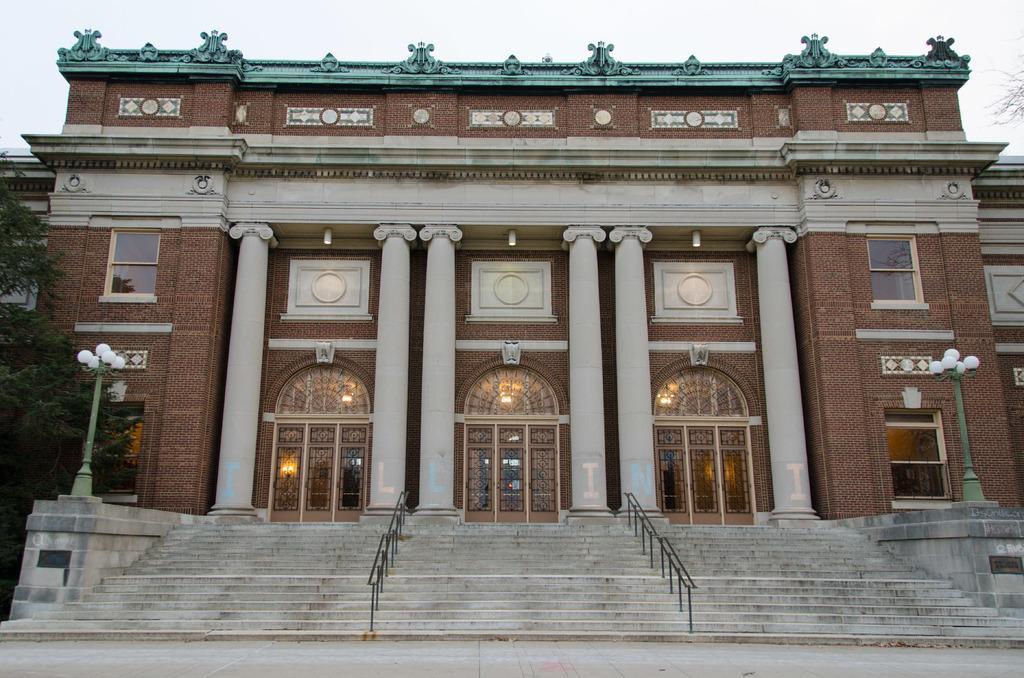How would you summarize this image in a sentence or two? This picture is clicked outside. In the foreground we can see the stairway and the handrails and we can see the lampposts, trees and the building and we can see the sculptures of some objects and we can see the pillars, windows and the doors of the building and we can see the lights. In the background we can see the sky. 